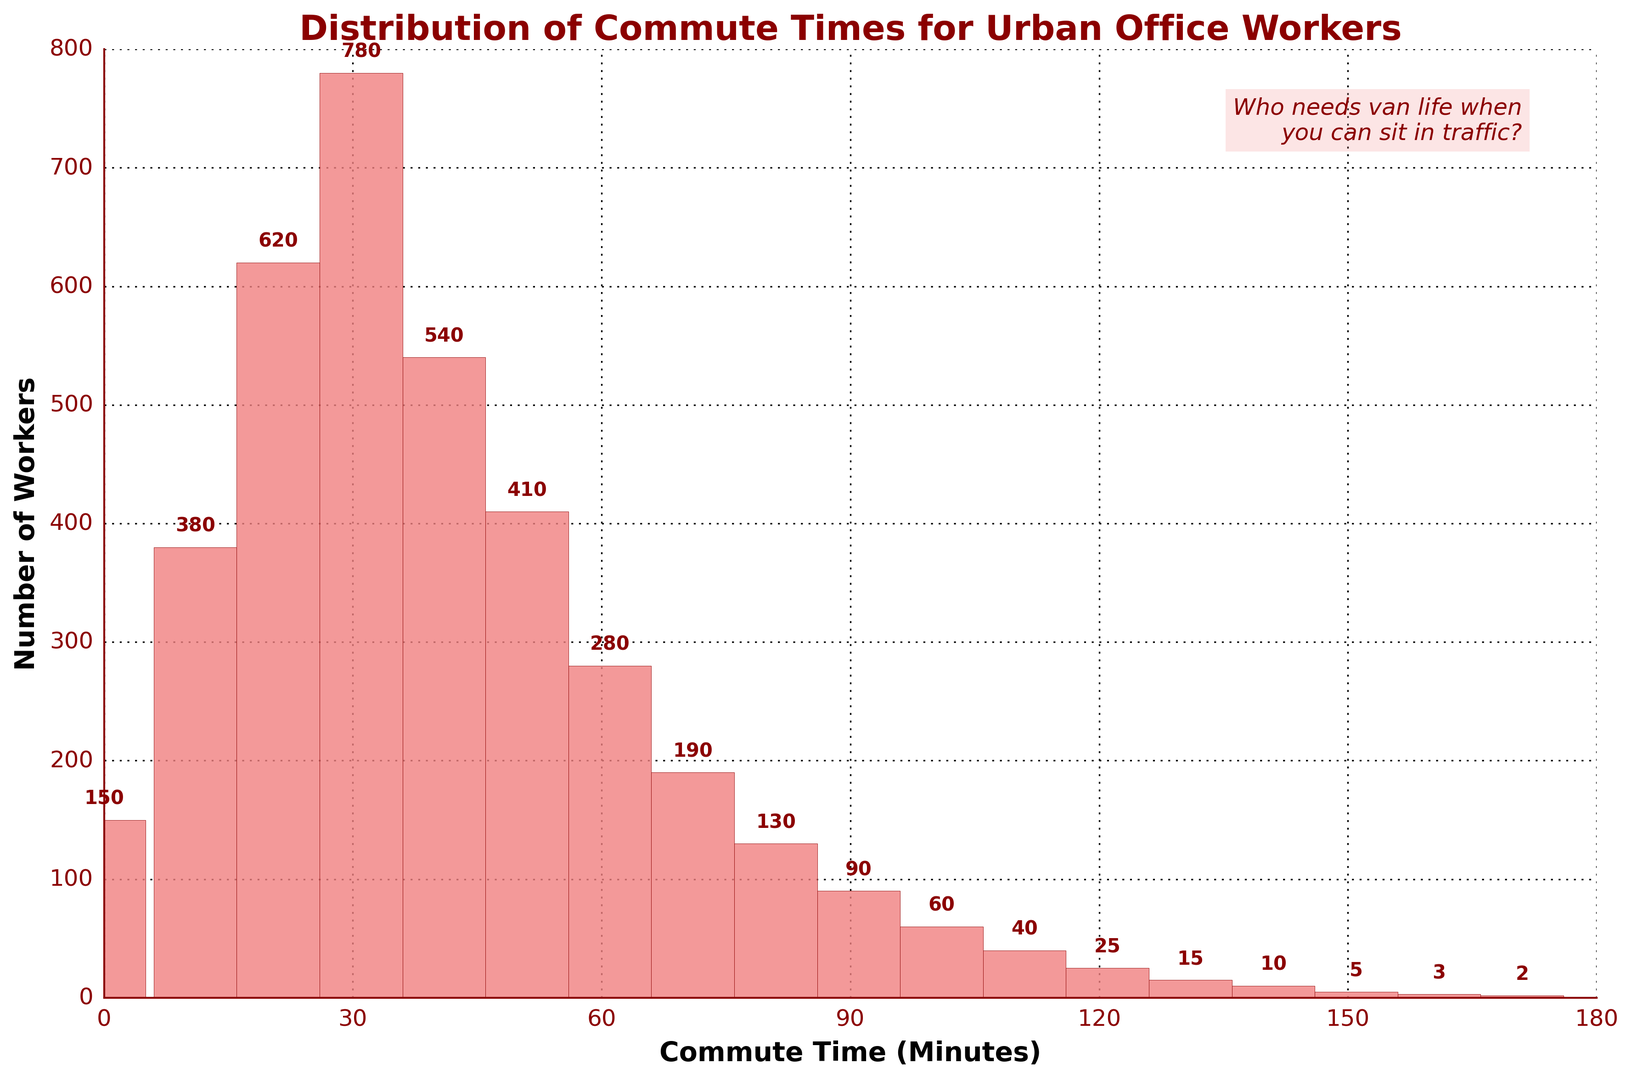Which commute time range has the highest number of workers? Look at the heights of the bars and identify the tallest one. The tallest bar is the one representing the 31-40 minutes range, which shows 780 workers.
Answer: 31-40 minutes Which commute time range has the fewest number of workers? Look for the smallest bar in the histogram, which is the bar representing the 171-180 minutes range with just 2 workers.
Answer: 171-180 minutes Compare the number of workers commuting 0-10 minutes with those commuting 91-100 minutes. Which group is larger? Observe the height of the bars for the 0-10 minute range (150 workers) and the 91-100 minute range (90 workers). Since 150 is greater than 90, the 0-10 minute group is larger.
Answer: 0-10 minutes What is the total number of workers who commute between 31-50 minutes? Add the number of workers in the 31-40 minute range (780) and the 41-50 minute range (540) to get the total. The sum is 780 + 540 = 1320.
Answer: 1320 How many workers commute for more than 60 minutes? Sum the workers in the commute ranges greater than 60 minutes: 61-70 (280), 71-80 (190), 81-90 (130), 91-100 (90), 101-110 (60), 111-120 (40), 121-130 (25), 131-140 (15), 141-150 (10), 151-160 (5), 161-170 (3), 171-180 (2). The total is 280 + 190 + 130 + 90 + 60 + 40 + 25 + 15 + 10 + 5 + 3 + 2 = 850.
Answer: 850 Does the number of workers increase or decrease as commute times exceed 40 minutes? Observe the pattern of the bar heights starting from the 41-50 minutes range onward. The heights of the bars generally decrease as the commute time increases beyond 40 minutes.
Answer: Decrease What is the combined number of workers commuting between 0-30 minutes? Add the number of workers in the 0-10 (150), 11-20 (380), and 21-30 (620) minute ranges. The total is 150 + 380 + 620 = 1150.
Answer: 1150 Is there any commute time range where precisely 40 workers commute? Look for a bar whose label indicates 40 workers. The 111-120 minute range precisely has 40 workers.
Answer: 111-120 minutes In which ranges do fewer than 50 workers commute? Identify ranges with bars showing fewer than 50 workers: 121-130 (25), 131-140 (15), 141-150 (10), 151-160 (5), 161-170 (3), 171-180 (2).
Answer: 121-130, 131-140, 141-150, 151-160, 161-170, 171-180 